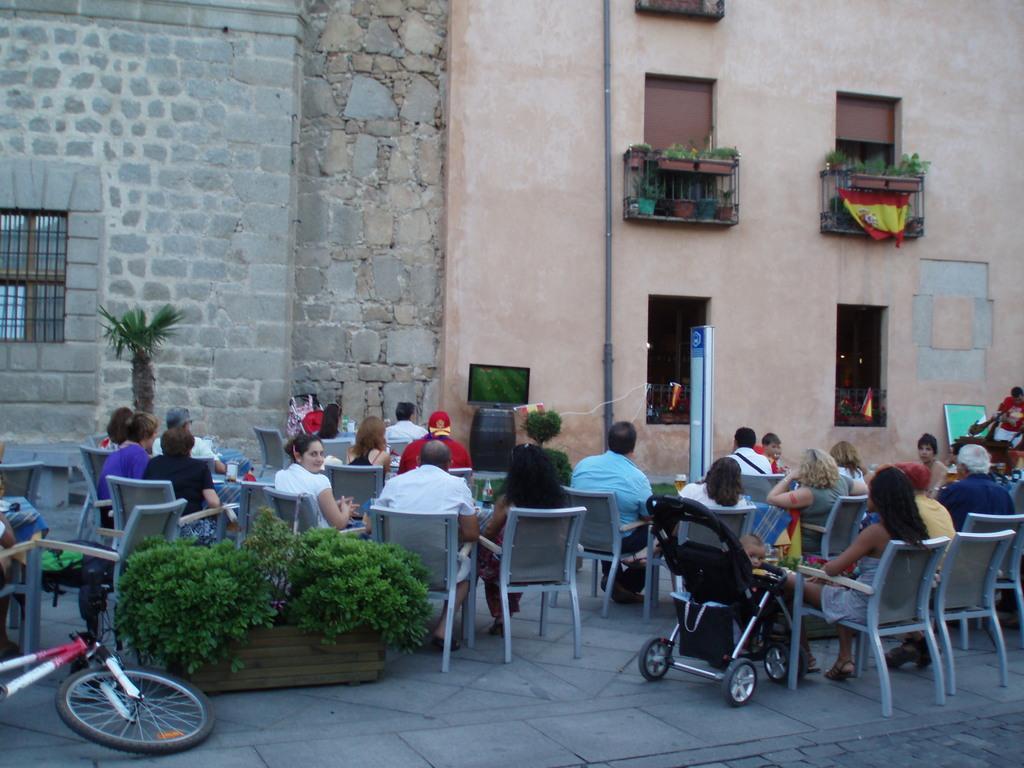In one or two sentences, can you explain what this image depicts? Here we can see a group of people sitting on the chair, and here is the bicycle on the floor, and here is the flower pot, and here is the building. 